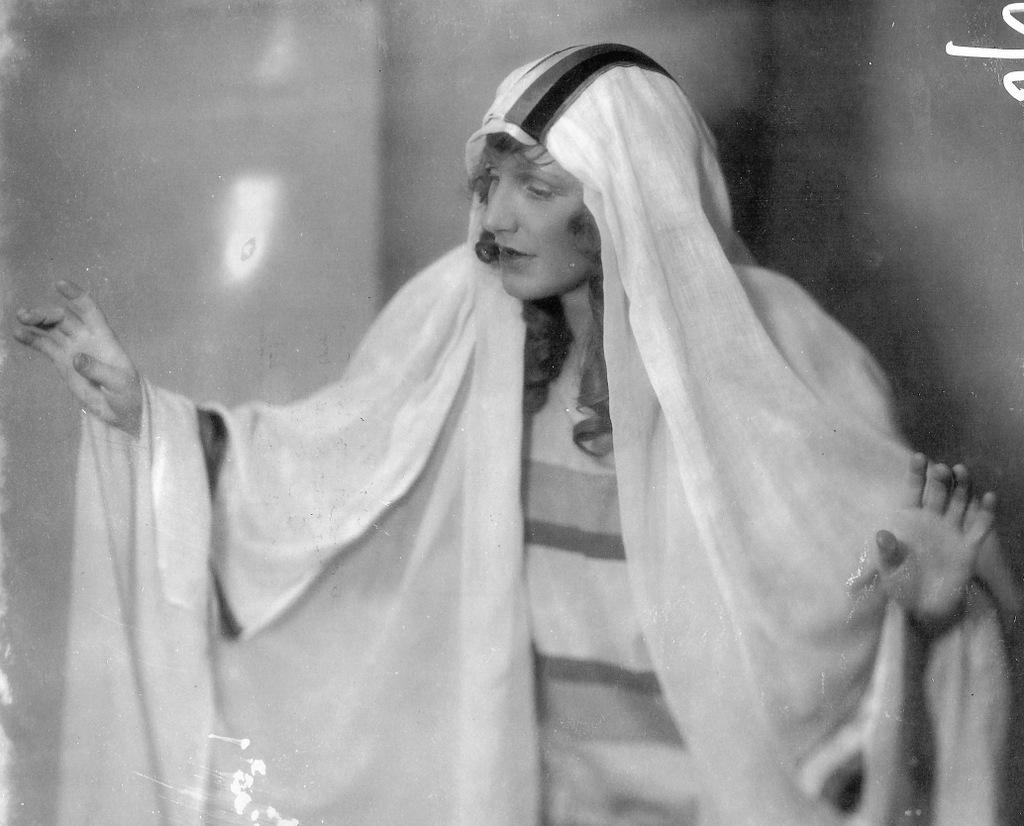Describe this image in one or two sentences. In this black and white picture there is a woman standing. Behind her there is a wall. 